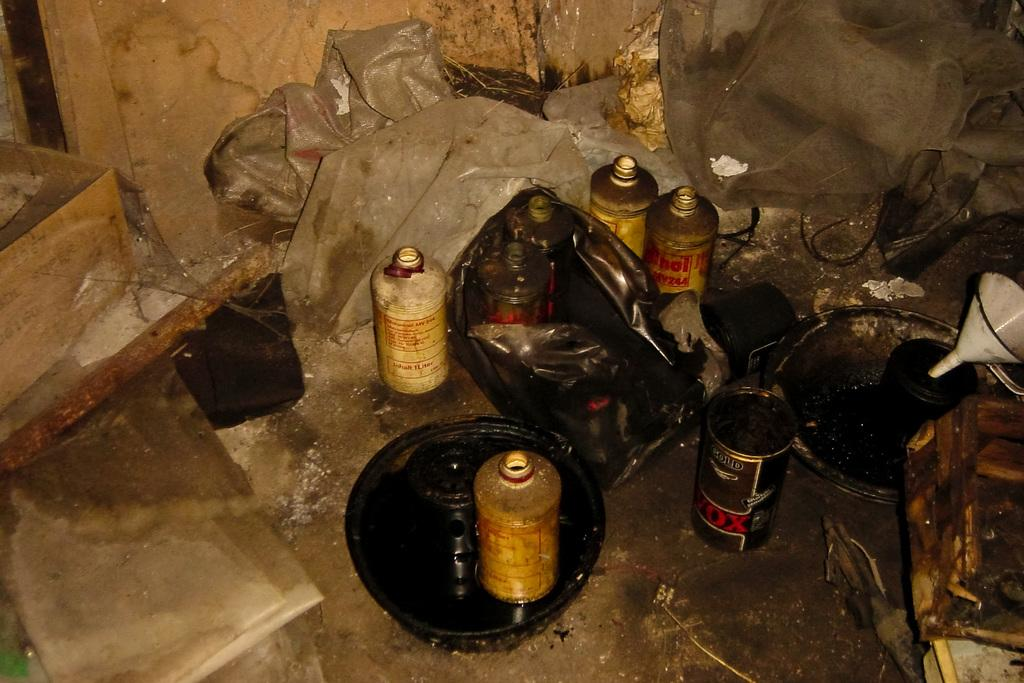How many bottles can be seen in the image? There are seven bottles in the image. What other objects are present in the image besides the bottles? There are bowls and a funnel visible in the image. What is located on the floor in the image? There is a wooden box on the floor in the image. What can be seen in the background of the image? There is a wall and covers visible in the background of the image. What type of clam is used to hold the funnel in place in the image? There is no clam present in the image; the funnel is not being held in place by any clam. 